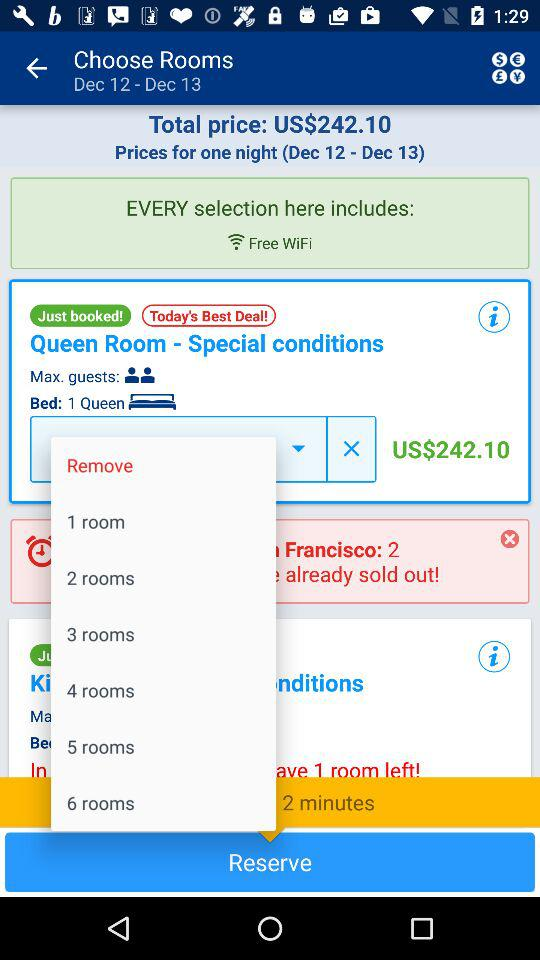Which bed size is selected? The selected bed size is queen. 